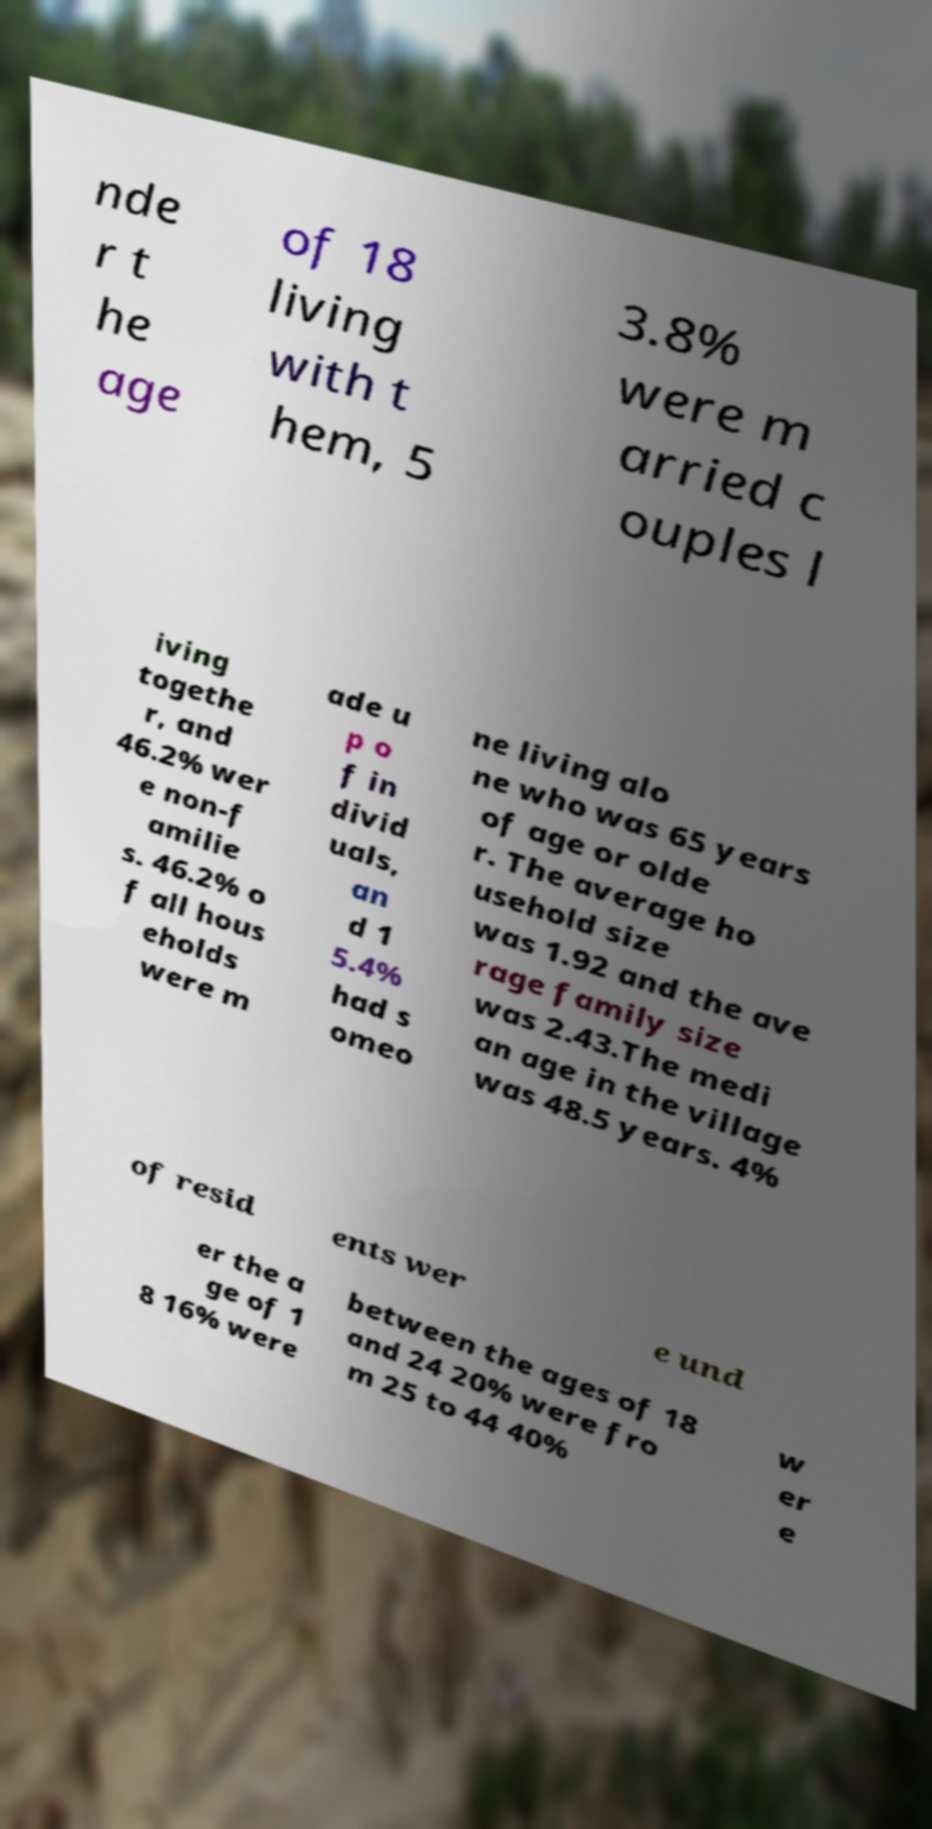Can you read and provide the text displayed in the image?This photo seems to have some interesting text. Can you extract and type it out for me? nde r t he age of 18 living with t hem, 5 3.8% were m arried c ouples l iving togethe r, and 46.2% wer e non-f amilie s. 46.2% o f all hous eholds were m ade u p o f in divid uals, an d 1 5.4% had s omeo ne living alo ne who was 65 years of age or olde r. The average ho usehold size was 1.92 and the ave rage family size was 2.43.The medi an age in the village was 48.5 years. 4% of resid ents wer e und er the a ge of 1 8 16% were between the ages of 18 and 24 20% were fro m 25 to 44 40% w er e 